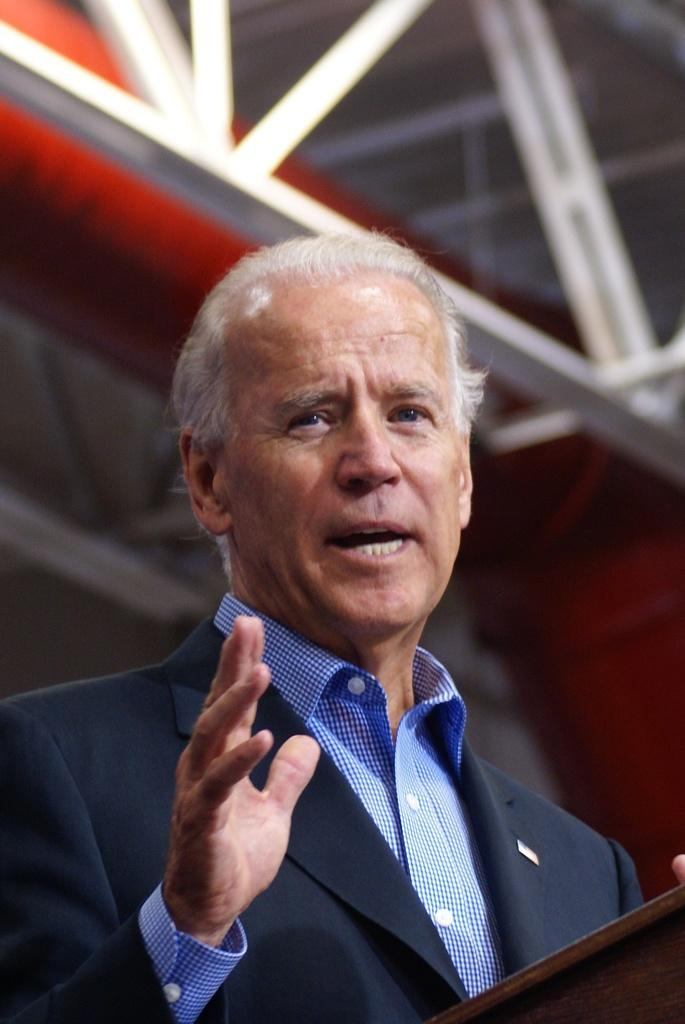Who is the main subject in the image? There is a man in the image. What is the man doing in the image? The man is standing in front of a podium and speaking. What is the man wearing in the image? The man is wearing a blue coat. What type of glove is the man wearing in the image? There is no glove visible in the image; the man is wearing a blue coat. 